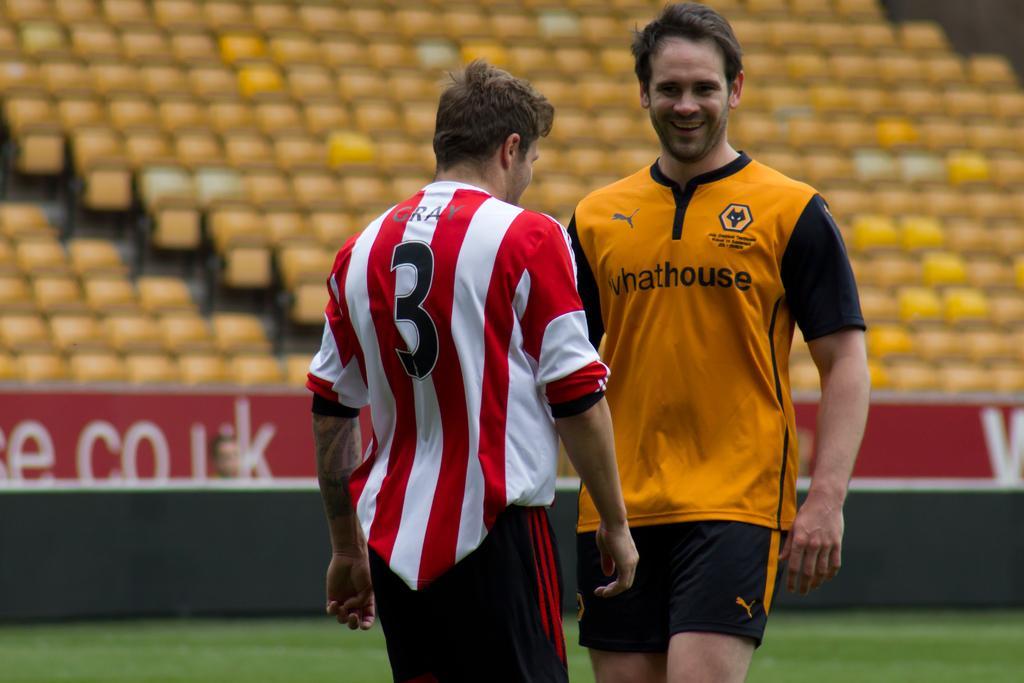In one or two sentences, can you explain what this image depicts? Here I can see two men wearing t-shirts, shorts and standing. The man who is on the right side is smiling. At the bottom I can see the grass. In the background there is a board on which I can see some text. At the top there are many empty chairs. 